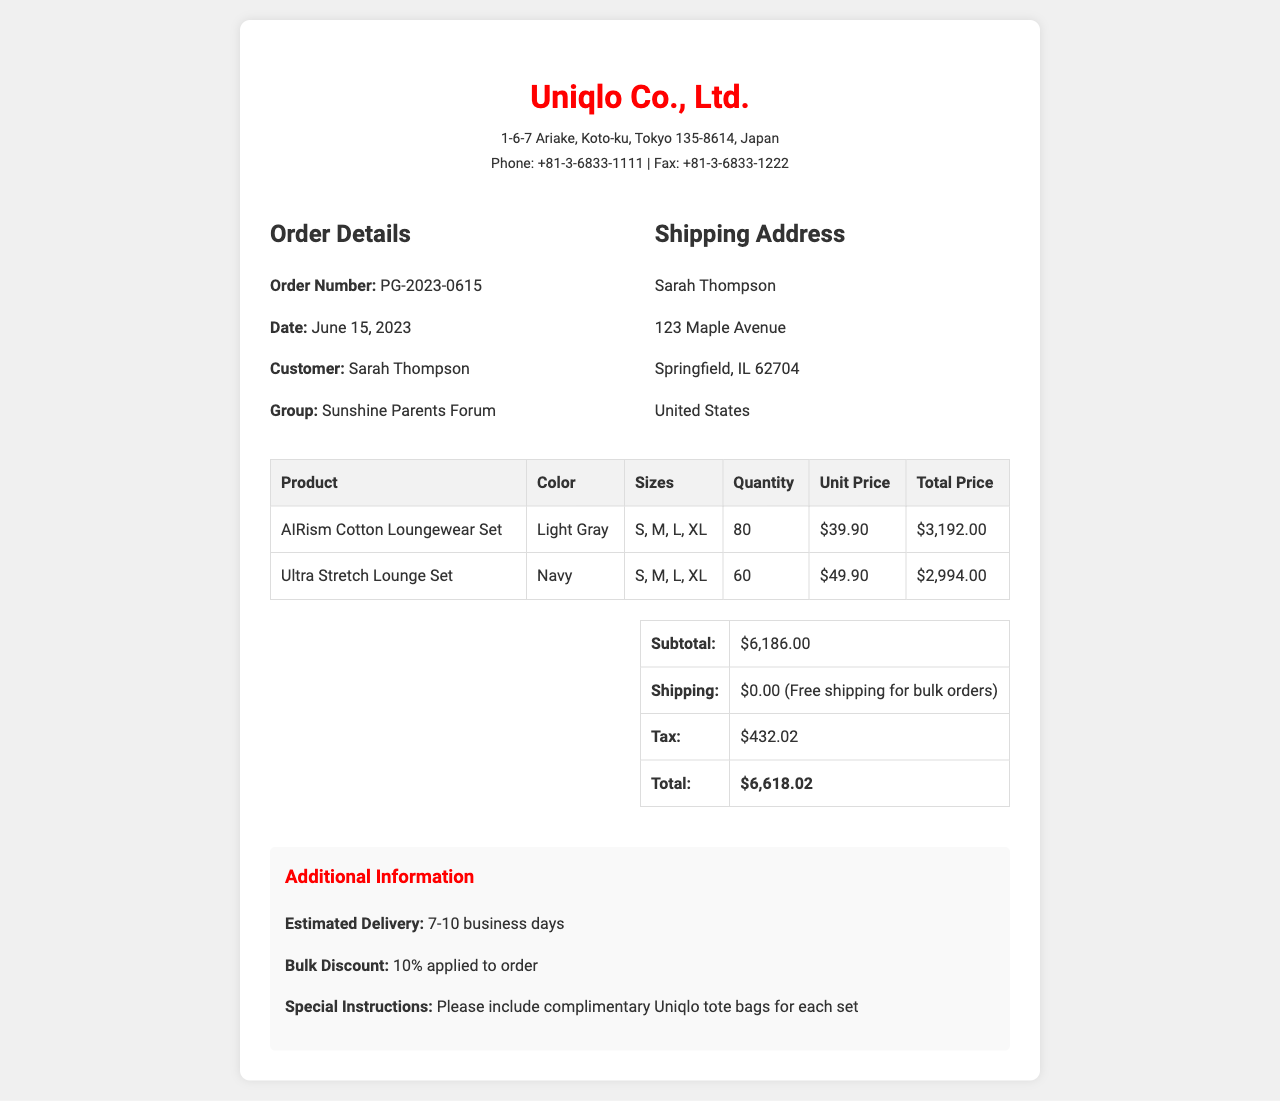What is the order number? The order number is clearly stated as PG-2023-0615 in the document.
Answer: PG-2023-0615 Who is the customer? The customer's name appears in the order details section as Sarah Thompson.
Answer: Sarah Thompson What is the total price of the order? The total price is the final amount calculated at the end of the summary table, which is $6,618.02.
Answer: $6,618.02 What is the estimated delivery timeframe? The estimated delivery timeframe is provided in the additional information section as 7-10 business days.
Answer: 7-10 business days How much was the bulk discount applied? The bulk discount is mentioned in the additional information section, indicating a 10% discount was applied to the order.
Answer: 10% What shipping cost was charged for this order? The shipping cost is presented in the summary table and it states that shipping is free for bulk orders.
Answer: $0.00 (Free shipping for bulk orders) What items are included in the order? The order includes two types of items: the AIRism Cotton Loungewear Set and the Ultra Stretch Lounge Set.
Answer: AIRism Cotton Loungewear Set, Ultra Stretch Lounge Set What special instructions were given for the order? The document mentions a special instruction to include complimentary Uniqlo tote bags for each set.
Answer: Include complimentary Uniqlo tote bags for each set Which color is the Ultra Stretch Lounge Set? The color of the Ultra Stretch Lounge Set is provided in the table as Navy.
Answer: Navy 